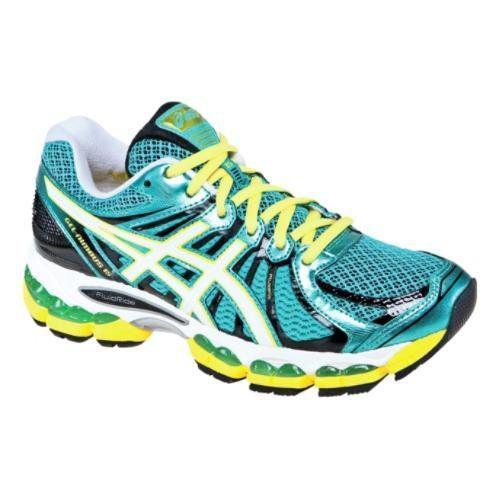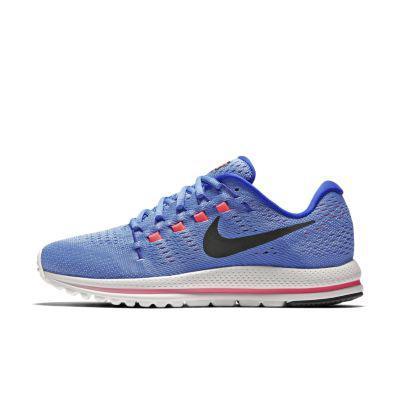The first image is the image on the left, the second image is the image on the right. Analyze the images presented: Is the assertion "there is only one shoe on the right image on a white background" valid? Answer yes or no. Yes. 